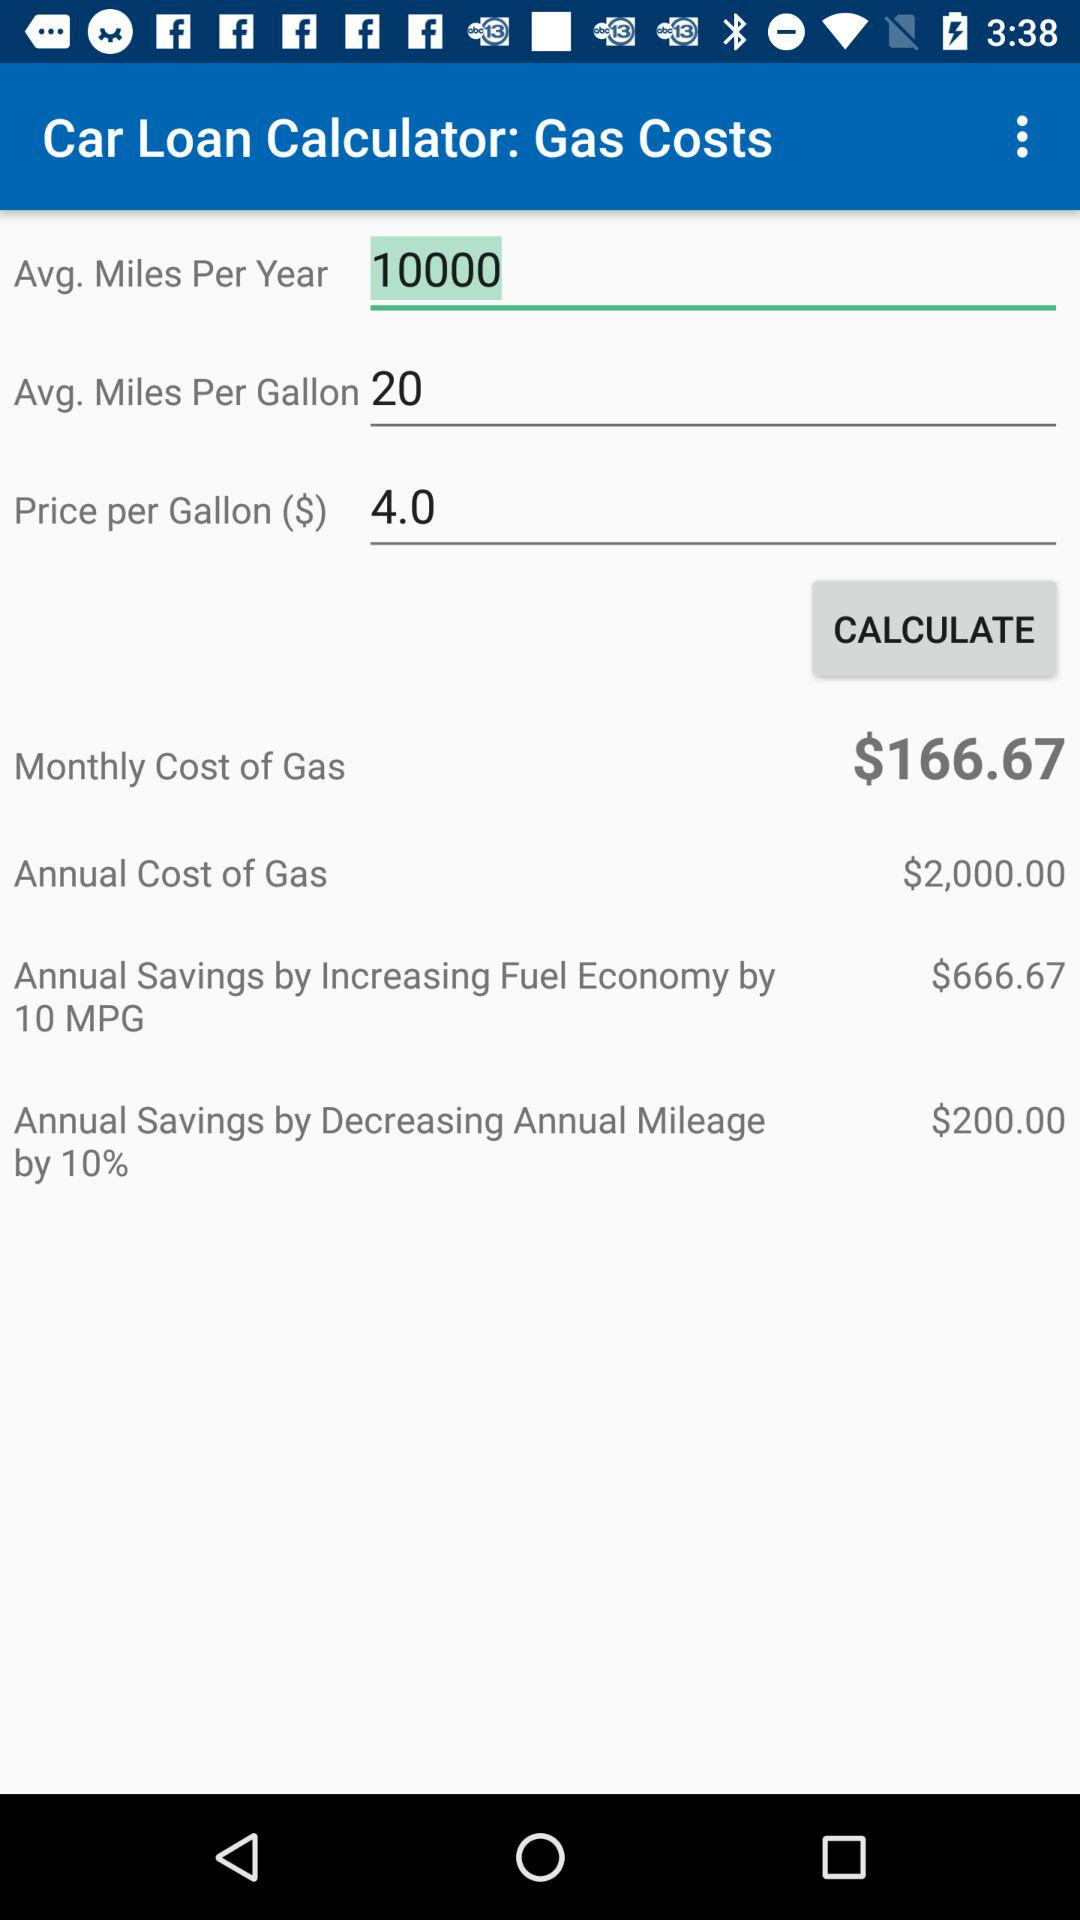What is the avg. number of miles per year? The avg. number of miles per year is 10,000. 